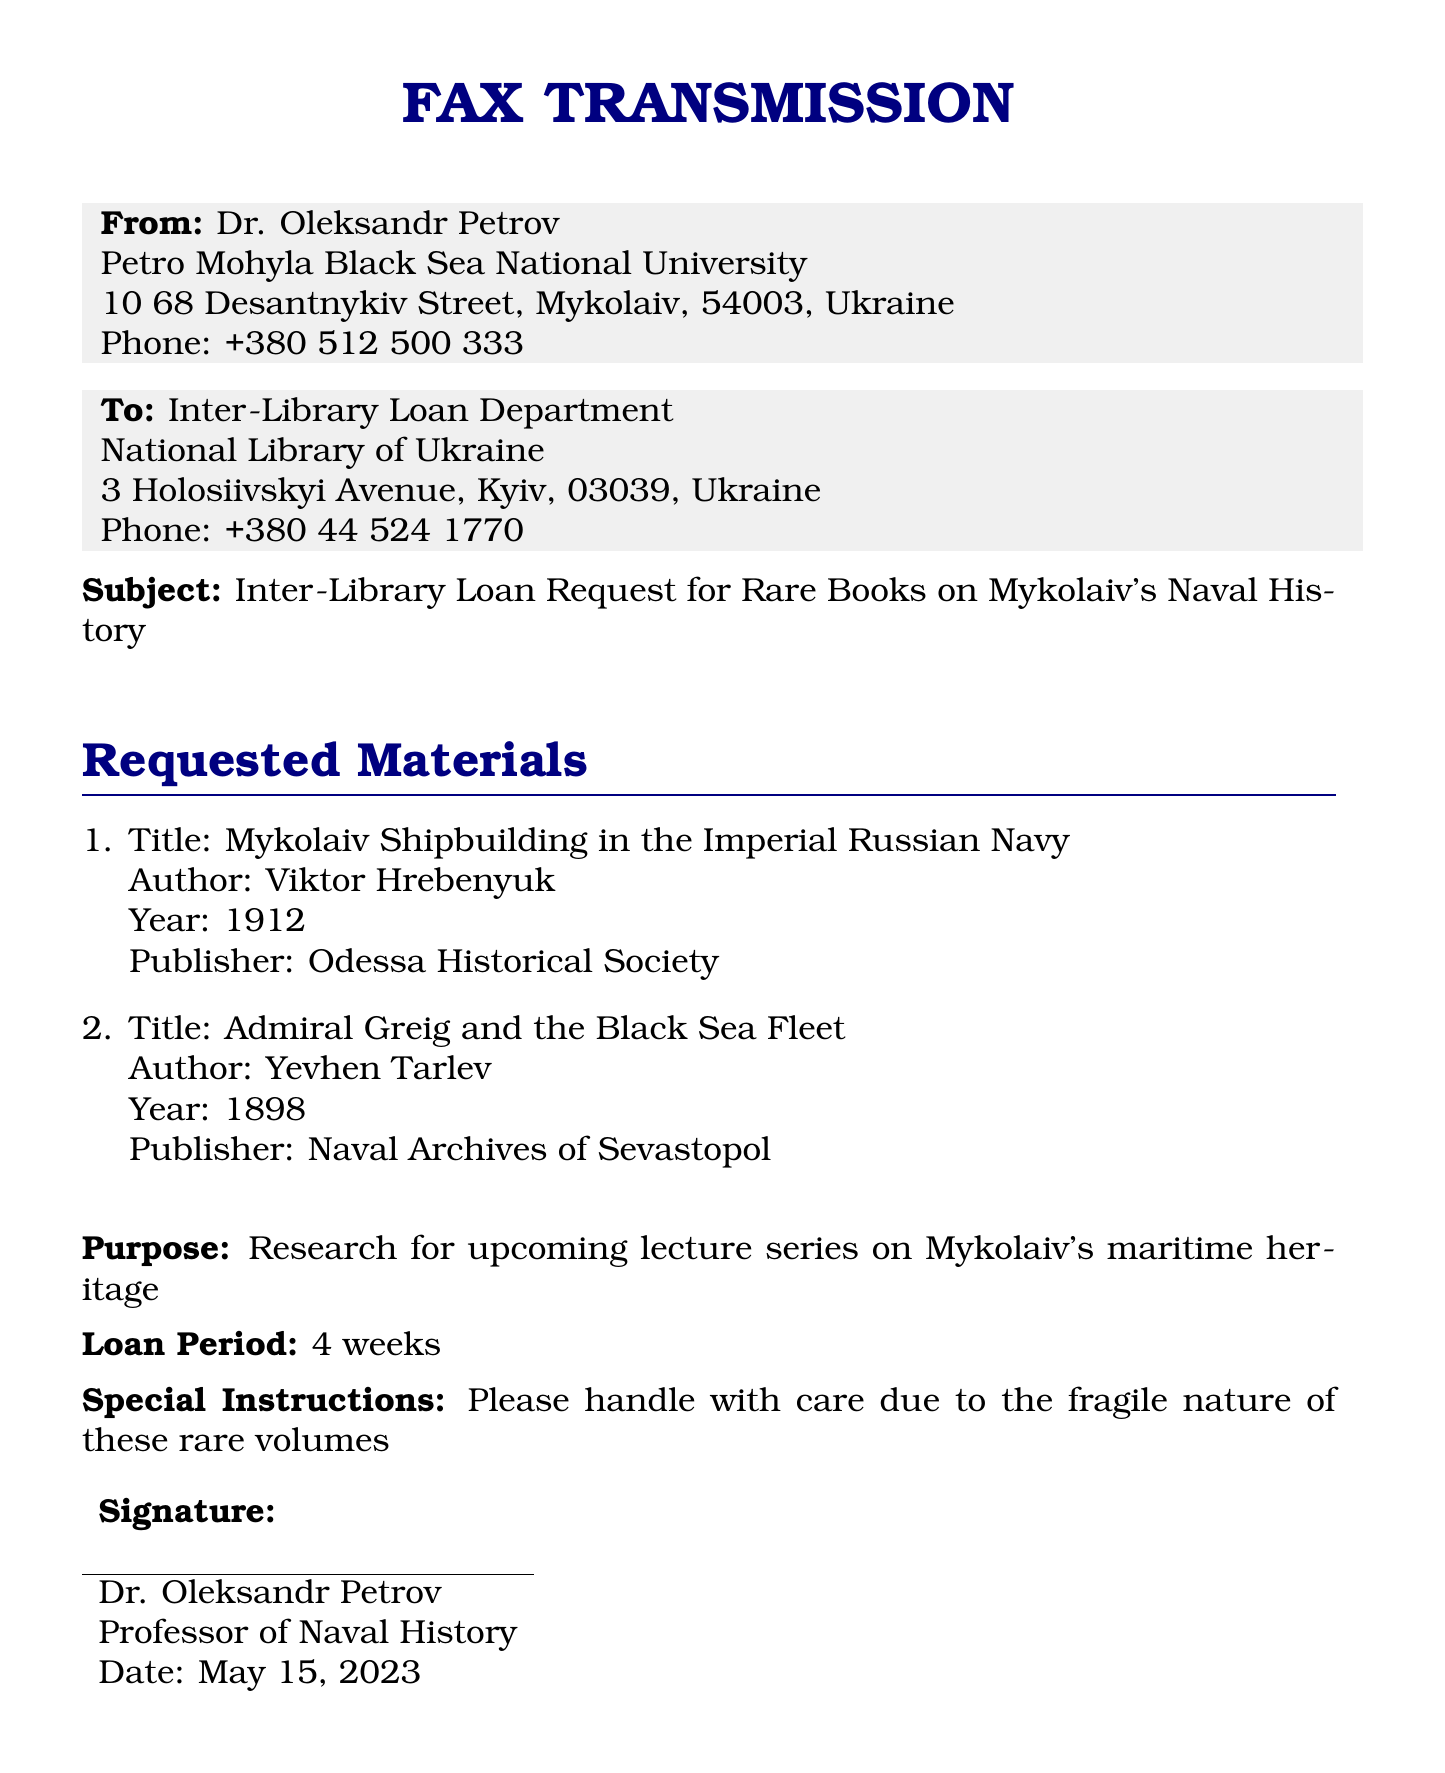what is the sender's name? The sender's name is provided in the document and is listed as Dr. Oleksandr Petrov.
Answer: Dr. Oleksandr Petrov who is the recipient of the fax? The recipient of the fax is mentioned in the document as the Inter-Library Loan Department at the National Library of Ukraine.
Answer: Inter-Library Loan Department what is the subject of the fax? The subject indicates the reason for the fax; it is stated clearly in the document.
Answer: Inter-Library Loan Request for Rare Books on Mykolaiv's Naval History how many books are requested? The document lists the number of requested materials in the enumerated section.
Answer: 2 what is the loan period requested? The loan period for the books is specified in the document, indicating how long the materials will be borrowed.
Answer: 4 weeks what is the purpose of the book request? The purpose of the request is stated in the document, indicating the academic activity it is related to.
Answer: Research for upcoming lecture series on Mykolaiv's maritime heritage who is the author of the first book requested? The author of the first book can be found in the description of the requested materials section.
Answer: Viktor Hrebenyuk what special instructions are given regarding the books? The document includes a note on how the books should be treated due to their condition.
Answer: Please handle with care due to the fragile nature of these rare volumes what is the date of the request? The date is included at the end of the document as part of the sender's signature.
Answer: May 15, 2023 